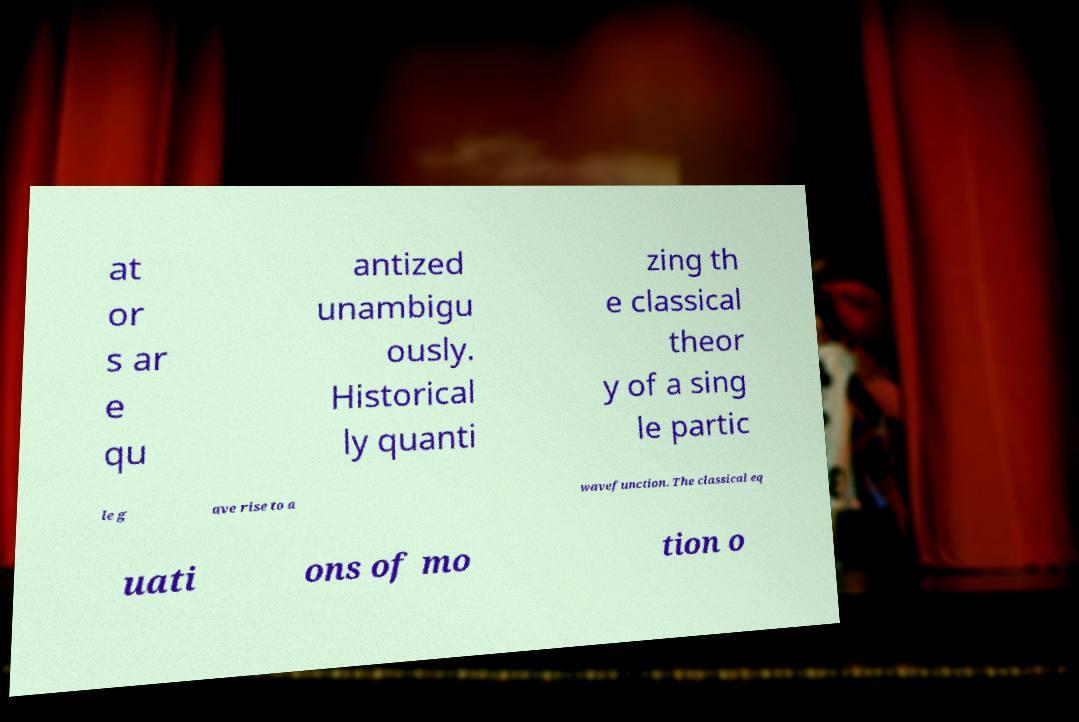There's text embedded in this image that I need extracted. Can you transcribe it verbatim? at or s ar e qu antized unambigu ously. Historical ly quanti zing th e classical theor y of a sing le partic le g ave rise to a wavefunction. The classical eq uati ons of mo tion o 